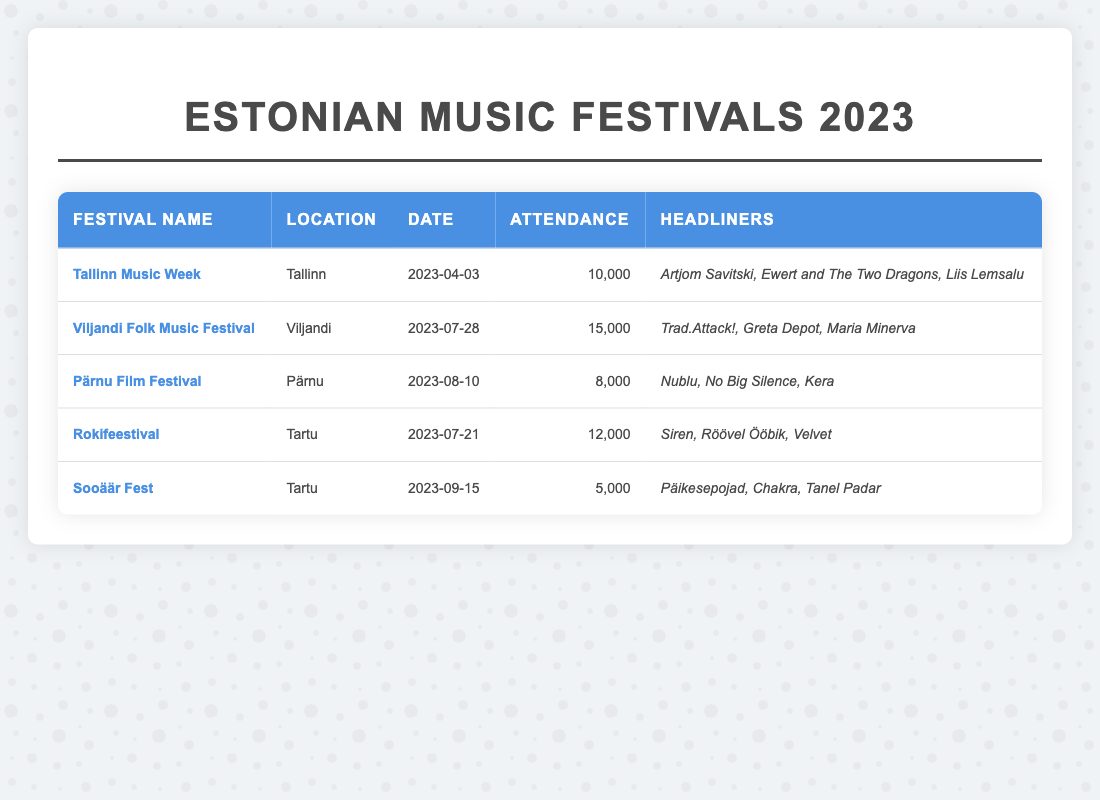What's the location of the Tallinn Music Week? The table shows that the location of the Tallinn Music Week is listed under the "Location" column in the respective row for this festival.
Answer: Tallinn Who are the headliners for the Viljandi Folk Music Festival? By looking at the "Headliners" column for the Viljandi Folk Music Festival row, we find the artists mentioned.
Answer: Trad.Attack!, Greta Depot, Maria Minerva What was the attendance at the Pärnu Film Festival? The attendance figure can be found in the "Attendance" column for the Pärnu Film Festival row.
Answer: 8000 Which festival had the highest attendance? By comparing the attendance values across all festivals in the "Attendance" column, it is clear that the Viljandi Folk Music Festival has the highest attendance of 15,000.
Answer: Viljandi Folk Music Festival What is the average attendance for the festivals listed? To find the average, we sum the attendances: 10,000 + 15,000 + 8,000 + 12,000 + 5,000 = 50,000. There are 5 festivals, so the average attendance is 50,000 / 5 = 10,000.
Answer: 10000 Which festival took place in Tartu, and what was its attendance? The table shows two festivals in Tartu: Rokifeestival and Sooäär Fest. By referencing their respective rows, we see that Rokifeestival had an attendance of 12,000 and Sooäär Fest had 5,000.
Answer: Rokifeestival (12000), Sooäär Fest (5000) Is Artjom Savitski a headliner for any festival in 2023? A quick look at the "Headliners" column shows that Artjom Savitski is listed as a headliner for the Tallinn Music Week.
Answer: Yes What is the difference in attendance between the Viljandi Folk Music Festival and Sooäär Fest? The attendance for the Viljandi Folk Music Festival is 15,000, while for Sooäär Fest it is 5,000. The difference is 15,000 - 5,000 = 10,000.
Answer: 10000 Which festival occurred last in the summer of 2023? By checking the "Date" column for all festivals that took place in the summer months (June to August), we see that the last one was the Pärnu Film Festival on August 10th.
Answer: Pärnu Film Festival How many more people attended the Rokifeestival compared to Sooäär Fest? Rokifeestival had an attendance of 12,000, and Sooäär Fest had 5,000. The difference is 12,000 - 5,000 = 7,000.
Answer: 7000 Did any festival have an attendance lower than 10,000? Looking at the "Attendance" column, both the Pärnu Film Festival (8,000) and Sooäär Fest (5,000) had attendances below 10,000.
Answer: Yes 